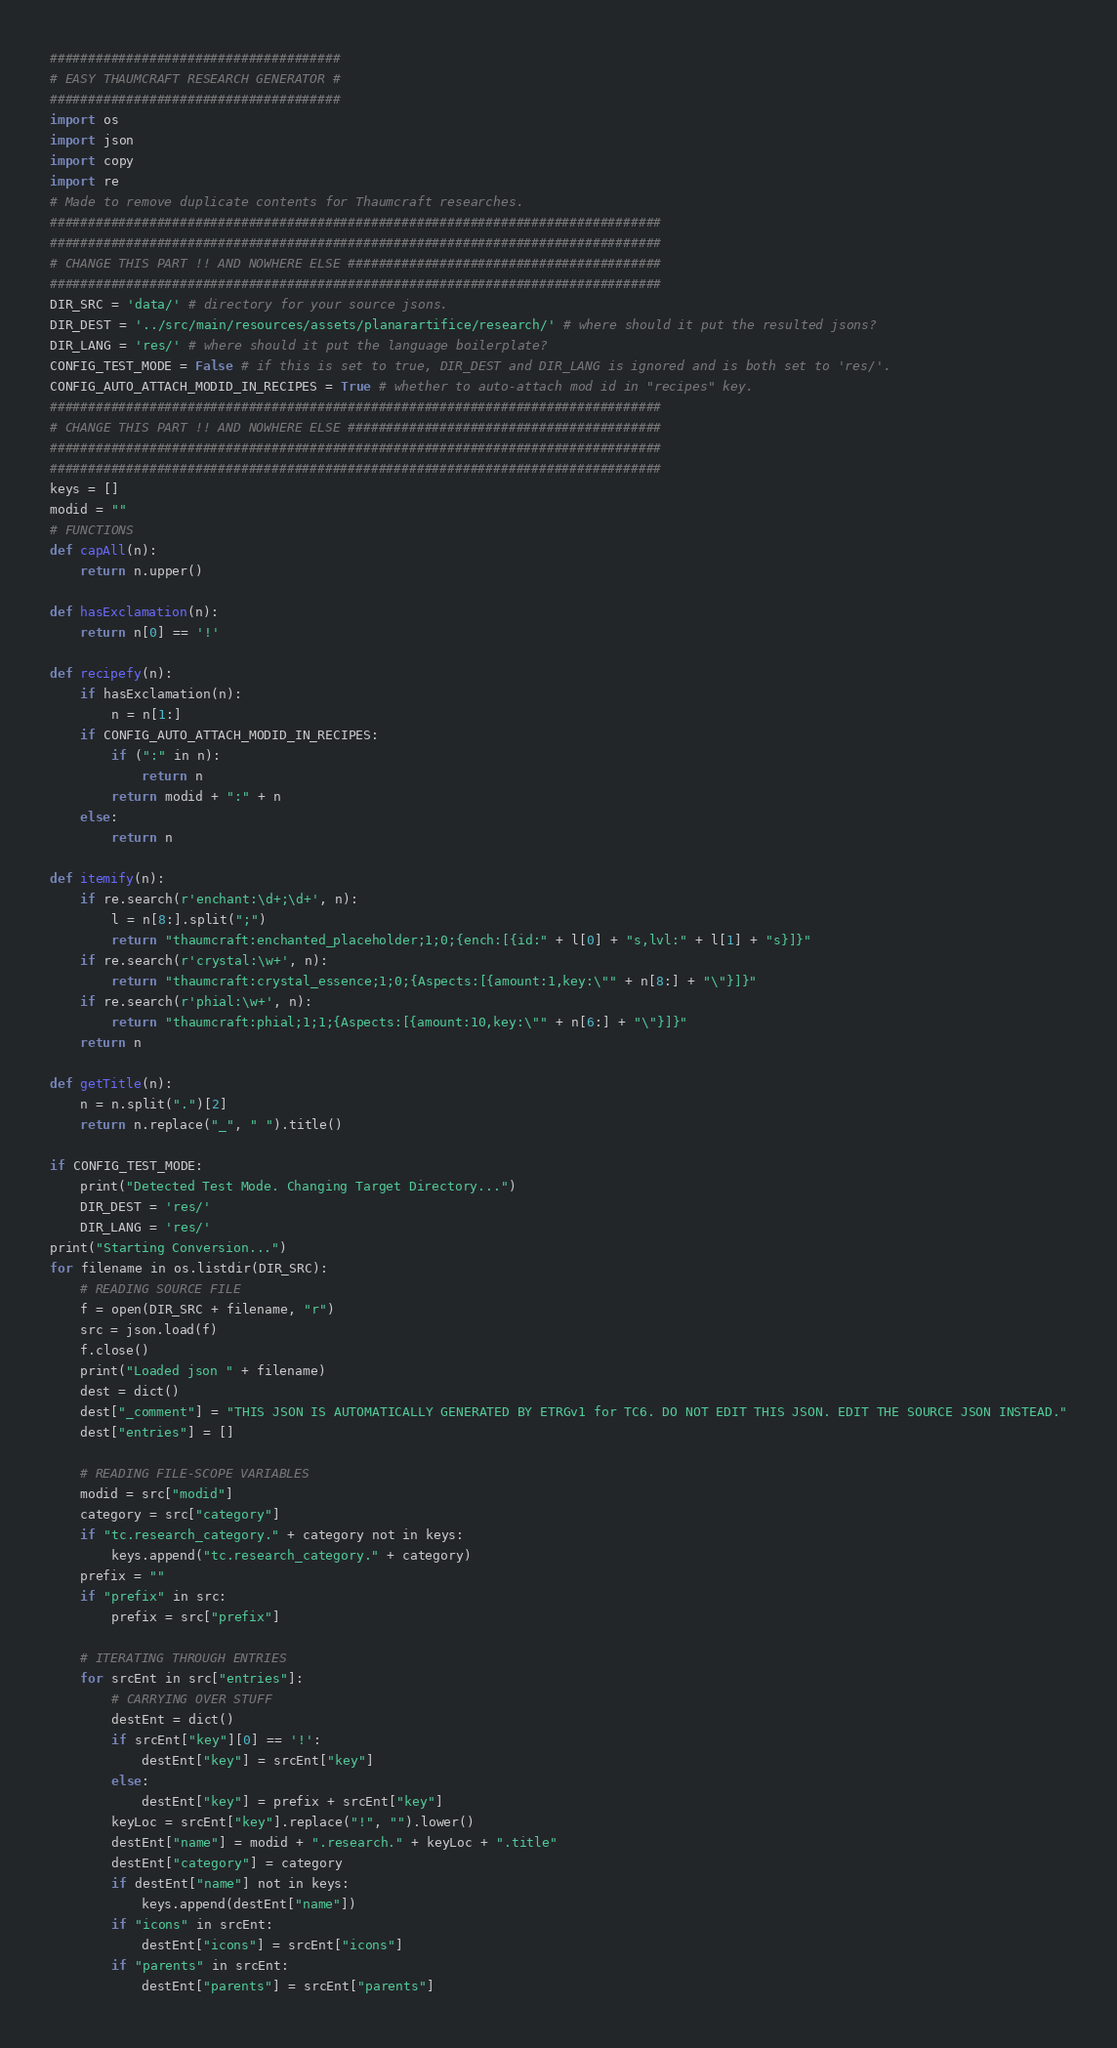Convert code to text. <code><loc_0><loc_0><loc_500><loc_500><_Python_>######################################
# EASY THAUMCRAFT RESEARCH GENERATOR #
######################################
import os
import json
import copy 
import re
# Made to remove duplicate contents for Thaumcraft researches.
################################################################################
################################################################################
# CHANGE THIS PART !! AND NOWHERE ELSE #########################################
################################################################################
DIR_SRC = 'data/' # directory for your source jsons.
DIR_DEST = '../src/main/resources/assets/planarartifice/research/' # where should it put the resulted jsons?
DIR_LANG = 'res/' # where should it put the language boilerplate?
CONFIG_TEST_MODE = False # if this is set to true, DIR_DEST and DIR_LANG is ignored and is both set to 'res/'.
CONFIG_AUTO_ATTACH_MODID_IN_RECIPES = True # whether to auto-attach mod id in "recipes" key.
################################################################################
# CHANGE THIS PART !! AND NOWHERE ELSE #########################################
################################################################################
################################################################################
keys = []
modid = ""
# FUNCTIONS
def capAll(n):
    return n.upper()

def hasExclamation(n):
    return n[0] == '!'

def recipefy(n):
    if hasExclamation(n):
        n = n[1:]
    if CONFIG_AUTO_ATTACH_MODID_IN_RECIPES:
        if (":" in n):
            return n
        return modid + ":" + n
    else:
        return n

def itemify(n):
    if re.search(r'enchant:\d+;\d+', n):
        l = n[8:].split(";")
        return "thaumcraft:enchanted_placeholder;1;0;{ench:[{id:" + l[0] + "s,lvl:" + l[1] + "s}]}"
    if re.search(r'crystal:\w+', n):
        return "thaumcraft:crystal_essence;1;0;{Aspects:[{amount:1,key:\"" + n[8:] + "\"}]}"
    if re.search(r'phial:\w+', n):
        return "thaumcraft:phial;1;1;{Aspects:[{amount:10,key:\"" + n[6:] + "\"}]}"
    return n

def getTitle(n):
    n = n.split(".")[2]
    return n.replace("_", " ").title()

if CONFIG_TEST_MODE:
    print("Detected Test Mode. Changing Target Directory...")
    DIR_DEST = 'res/'
    DIR_LANG = 'res/'
print("Starting Conversion...")
for filename in os.listdir(DIR_SRC):
    # READING SOURCE FILE
    f = open(DIR_SRC + filename, "r")
    src = json.load(f)
    f.close()
    print("Loaded json " + filename)
    dest = dict()
    dest["_comment"] = "THIS JSON IS AUTOMATICALLY GENERATED BY ETRGv1 for TC6. DO NOT EDIT THIS JSON. EDIT THE SOURCE JSON INSTEAD."
    dest["entries"] = []

    # READING FILE-SCOPE VARIABLES
    modid = src["modid"]
    category = src["category"]
    if "tc.research_category." + category not in keys:
        keys.append("tc.research_category." + category)
    prefix = ""
    if "prefix" in src:
        prefix = src["prefix"]

    # ITERATING THROUGH ENTRIES
    for srcEnt in src["entries"]:
        # CARRYING OVER STUFF
        destEnt = dict()
        if srcEnt["key"][0] == '!':
            destEnt["key"] = srcEnt["key"]
        else:
            destEnt["key"] = prefix + srcEnt["key"]
        keyLoc = srcEnt["key"].replace("!", "").lower()
        destEnt["name"] = modid + ".research." + keyLoc + ".title"
        destEnt["category"] = category
        if destEnt["name"] not in keys:
            keys.append(destEnt["name"])
        if "icons" in srcEnt:
            destEnt["icons"] = srcEnt["icons"]
        if "parents" in srcEnt:
            destEnt["parents"] = srcEnt["parents"]</code> 